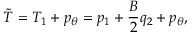Convert formula to latex. <formula><loc_0><loc_0><loc_500><loc_500>\tilde { T } = T _ { 1 } + p _ { \theta } = p _ { 1 } + \frac { B } { 2 } q _ { 2 } + p _ { \theta } ,</formula> 